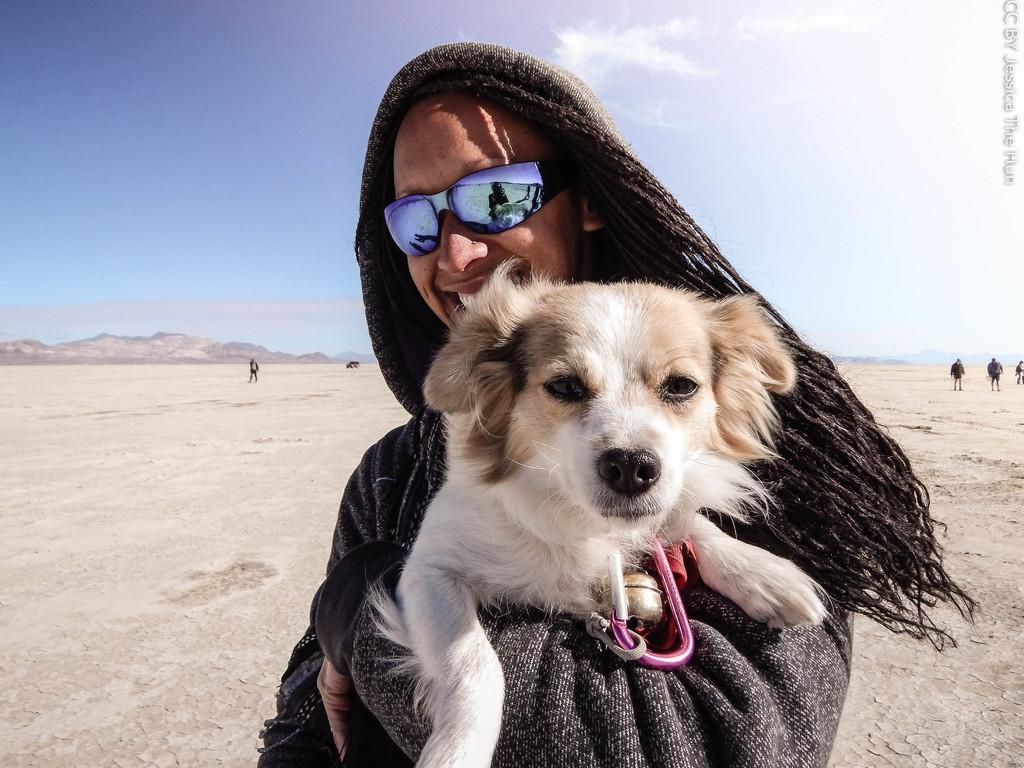Can you describe this image briefly? In this image I can see a person holding the dog. To the right there are few people walking. To the left there is a rock. In the background there is a sky. 